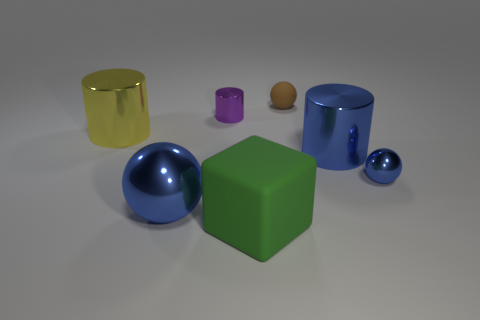Is the size of the brown ball the same as the matte cube?
Provide a succinct answer. No. The yellow cylinder that is made of the same material as the small purple cylinder is what size?
Ensure brevity in your answer.  Large. What number of large metal objects have the same color as the small metal ball?
Offer a terse response. 2. Are there fewer big rubber objects that are to the left of the purple cylinder than purple metallic objects behind the large green rubber cube?
Make the answer very short. Yes. There is a small metal object that is behind the large yellow cylinder; is it the same shape as the big yellow object?
Provide a succinct answer. Yes. Are the big cylinder that is left of the large green object and the large block made of the same material?
Your response must be concise. No. What is the material of the object in front of the large blue metal object that is left of the ball behind the yellow thing?
Offer a very short reply. Rubber. How many other objects are the same shape as the small brown object?
Offer a very short reply. 2. What color is the cylinder that is to the left of the big blue metallic ball?
Ensure brevity in your answer.  Yellow. What number of large yellow cylinders are left of the brown rubber sphere that is behind the large object on the left side of the big shiny sphere?
Keep it short and to the point. 1. 